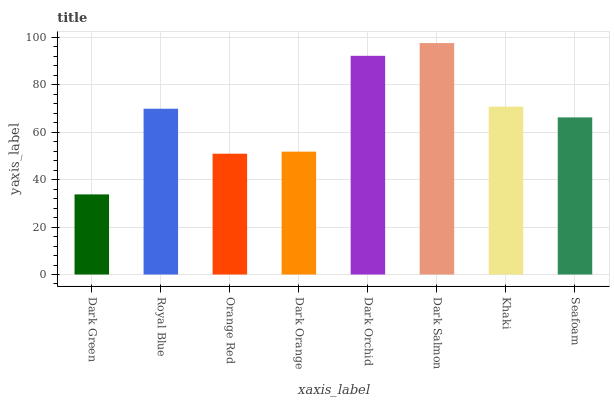Is Dark Green the minimum?
Answer yes or no. Yes. Is Dark Salmon the maximum?
Answer yes or no. Yes. Is Royal Blue the minimum?
Answer yes or no. No. Is Royal Blue the maximum?
Answer yes or no. No. Is Royal Blue greater than Dark Green?
Answer yes or no. Yes. Is Dark Green less than Royal Blue?
Answer yes or no. Yes. Is Dark Green greater than Royal Blue?
Answer yes or no. No. Is Royal Blue less than Dark Green?
Answer yes or no. No. Is Royal Blue the high median?
Answer yes or no. Yes. Is Seafoam the low median?
Answer yes or no. Yes. Is Dark Orange the high median?
Answer yes or no. No. Is Orange Red the low median?
Answer yes or no. No. 